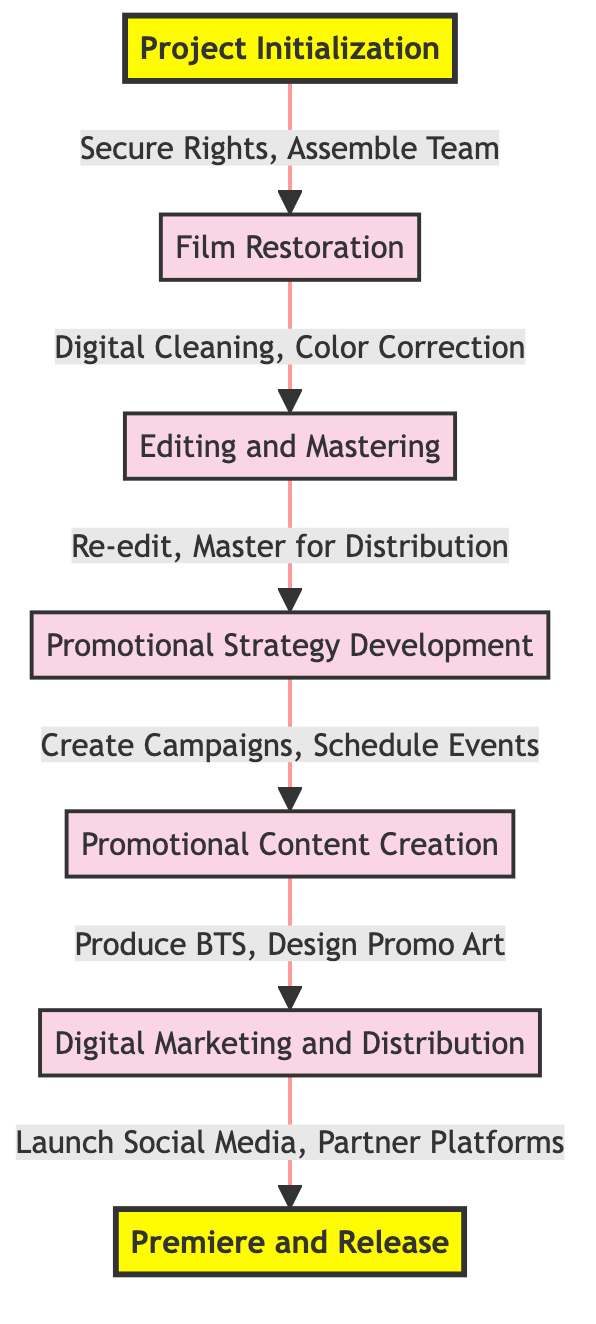What is the first step in the process? The first step in the flowchart is "Project Initialization," which is the starting point of the entire process.
Answer: Project Initialization How many main steps are outlined in the diagram? The diagram outlines seven main steps, ranging from project initialization to the premiere and release of the film.
Answer: Seven What action is performed after film restoration? After film restoration, the next action is "Editing and Mastering," which indicates a sequential process from restoring the film to preparing it for release.
Answer: Editing and Mastering Which step involves creating promotional materials? The step involving creating promotional materials is "Promotional Content Creation," where various materials like behind-the-scenes footage and promotional art are produced.
Answer: Promotional Content Creation How does digital marketing relate to distribution? "Digital Marketing and Distribution" follows after "Promotional Content Creation," indicating that once promotional content is created, marketing efforts are implemented to ensure the film's distribution across various channels.
Answer: Launch Social Media Campaign What two actions are part of the film restoration process? Two actions that are part of the film restoration process include "Transfer Original Film to Digital Format" and "Perform Digital Cleaning and Restoration," signifying the initial efforts to restore the film.
Answer: Transfer Original Film to Digital Format, Perform Digital Cleaning and Restoration What is the purpose of identifying the target audience? Identifying the target audience is crucial for "Promotional Strategy Development" as it helps tailor the marketing campaign effectively to engage specific groups that would be interested in the classic film.
Answer: Tailor the marketing campaign What comes before the premiere event in the process? Before the premiere event, "Digital Marketing and Distribution" takes place, which is essential for generating buzz and excitement leading up to the film's release.
Answer: Digital Marketing and Distribution 